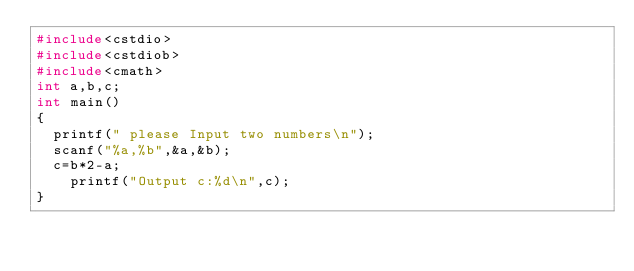Convert code to text. <code><loc_0><loc_0><loc_500><loc_500><_C_>#include<cstdio>
#include<cstdiob>
#include<cmath>
int a,b,c;
int main()
{
	printf(" please Input two numbers\n");
	scanf("%a,%b",&a,&b);
	c=b*2-a;
    printf("Output c:%d\n",c);
}
</code> 